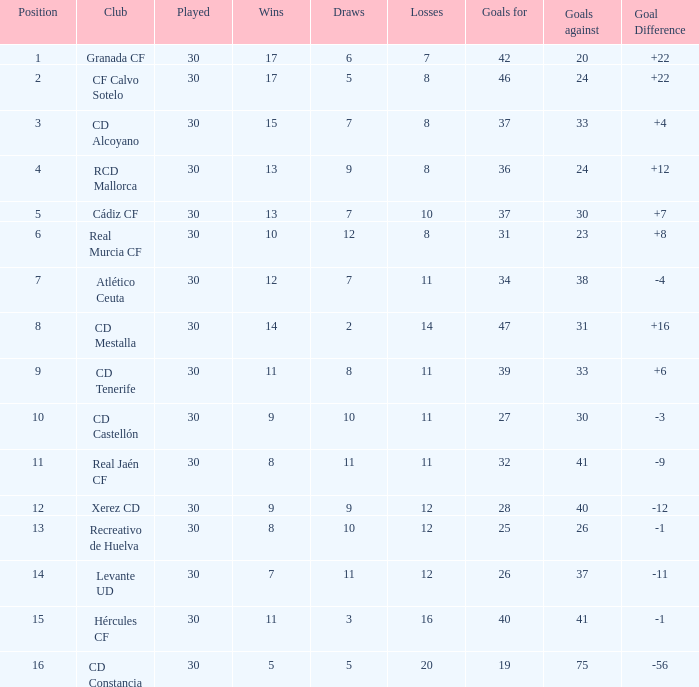How many Draws have 30 Points, and less than 33 Goals against? 1.0. 